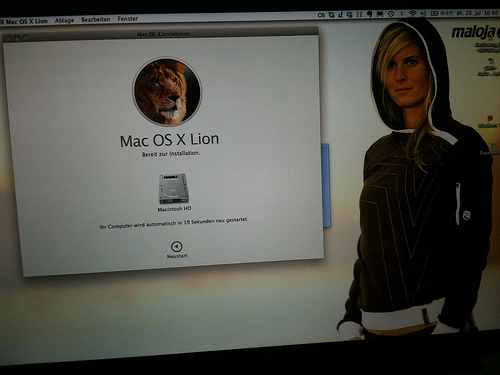<image>
Is the person in front of the lion? Yes. The person is positioned in front of the lion, appearing closer to the camera viewpoint. 